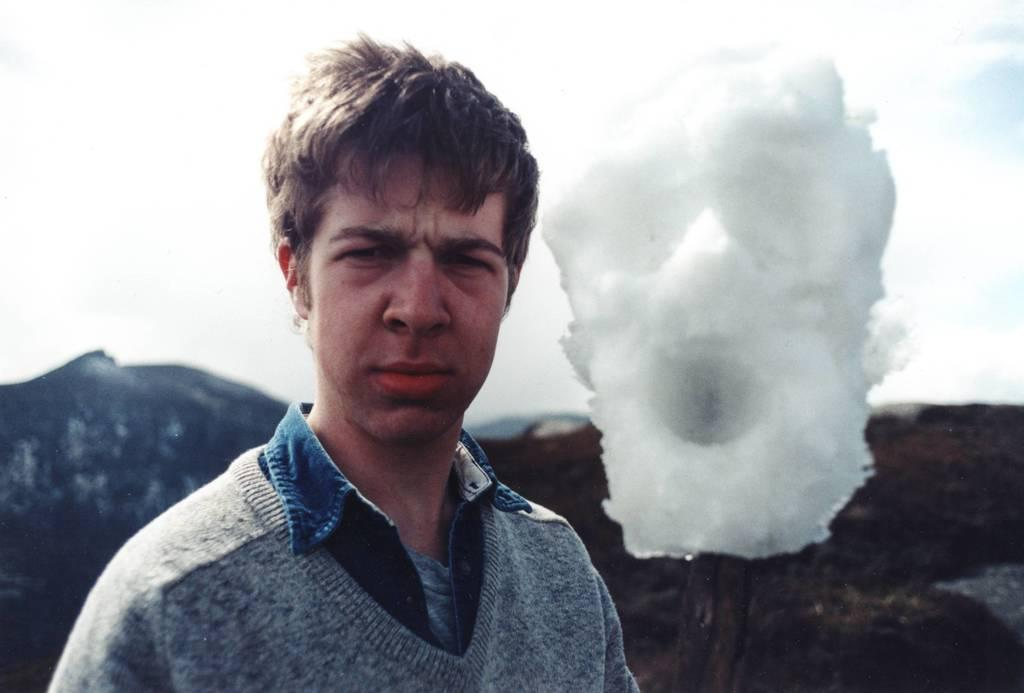Who or what is in the front of the image? There is a person in the front of the image. What color is the background of the image? The background of the image is blue. What can be seen in the distance in the image? There is a hill in the background of the image. What else is visible in the background of the image? The sky and other objects are visible in the background of the image. Can you hear the sound of thunder in the image? There is no sound present in the image, so it is not possible to hear thunder or any other sounds. 